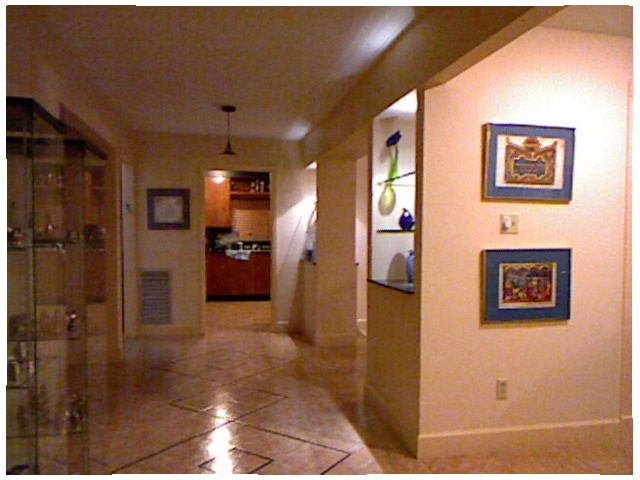<image>
Is the photo frame under the switch board? Yes. The photo frame is positioned underneath the switch board, with the switch board above it in the vertical space. Is the floor on the wall? No. The floor is not positioned on the wall. They may be near each other, but the floor is not supported by or resting on top of the wall. Is the picture above the picture? Yes. The picture is positioned above the picture in the vertical space, higher up in the scene. 